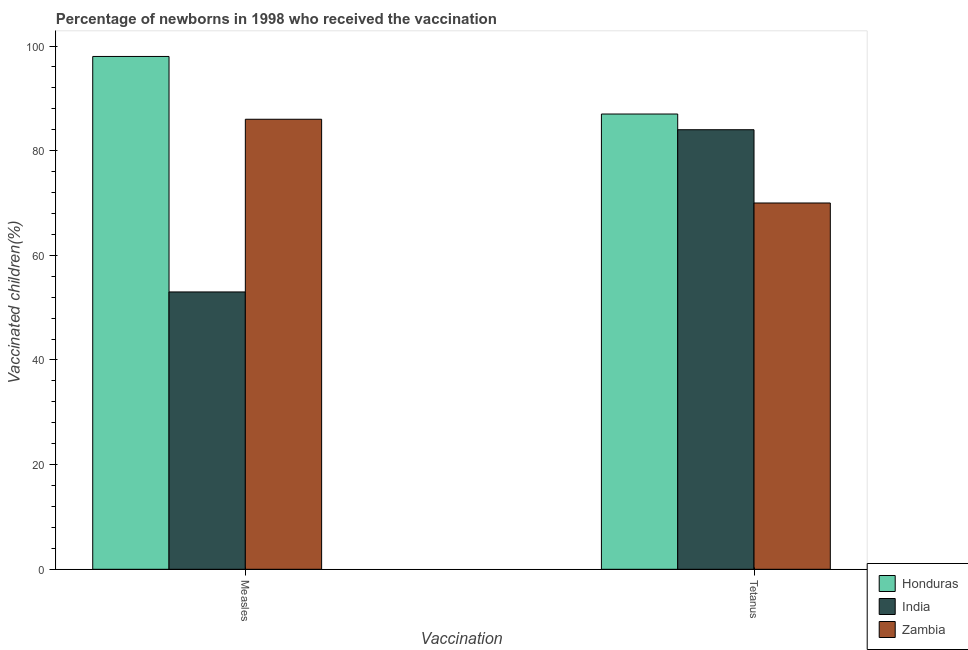How many different coloured bars are there?
Give a very brief answer. 3. Are the number of bars per tick equal to the number of legend labels?
Offer a very short reply. Yes. Are the number of bars on each tick of the X-axis equal?
Provide a succinct answer. Yes. How many bars are there on the 1st tick from the left?
Keep it short and to the point. 3. How many bars are there on the 1st tick from the right?
Your answer should be very brief. 3. What is the label of the 2nd group of bars from the left?
Make the answer very short. Tetanus. What is the percentage of newborns who received vaccination for measles in Honduras?
Provide a succinct answer. 98. Across all countries, what is the maximum percentage of newborns who received vaccination for tetanus?
Offer a very short reply. 87. Across all countries, what is the minimum percentage of newborns who received vaccination for tetanus?
Your response must be concise. 70. In which country was the percentage of newborns who received vaccination for measles maximum?
Ensure brevity in your answer.  Honduras. In which country was the percentage of newborns who received vaccination for measles minimum?
Provide a short and direct response. India. What is the total percentage of newborns who received vaccination for measles in the graph?
Your response must be concise. 237. What is the difference between the percentage of newborns who received vaccination for measles in Honduras and that in India?
Ensure brevity in your answer.  45. What is the difference between the percentage of newborns who received vaccination for measles in Zambia and the percentage of newborns who received vaccination for tetanus in India?
Keep it short and to the point. 2. What is the average percentage of newborns who received vaccination for tetanus per country?
Provide a succinct answer. 80.33. What is the difference between the percentage of newborns who received vaccination for measles and percentage of newborns who received vaccination for tetanus in Honduras?
Provide a short and direct response. 11. What does the 3rd bar from the left in Tetanus represents?
Make the answer very short. Zambia. What does the 3rd bar from the right in Tetanus represents?
Your response must be concise. Honduras. How many bars are there?
Provide a succinct answer. 6. Are all the bars in the graph horizontal?
Provide a succinct answer. No. What is the difference between two consecutive major ticks on the Y-axis?
Your answer should be compact. 20. Are the values on the major ticks of Y-axis written in scientific E-notation?
Provide a short and direct response. No. What is the title of the graph?
Your answer should be very brief. Percentage of newborns in 1998 who received the vaccination. What is the label or title of the X-axis?
Your answer should be very brief. Vaccination. What is the label or title of the Y-axis?
Make the answer very short. Vaccinated children(%)
. What is the Vaccinated children(%)
 of Honduras in Tetanus?
Give a very brief answer. 87. What is the Vaccinated children(%)
 in India in Tetanus?
Ensure brevity in your answer.  84. What is the Vaccinated children(%)
 in Zambia in Tetanus?
Give a very brief answer. 70. Across all Vaccination, what is the maximum Vaccinated children(%)
 in India?
Provide a succinct answer. 84. Across all Vaccination, what is the maximum Vaccinated children(%)
 in Zambia?
Offer a terse response. 86. Across all Vaccination, what is the minimum Vaccinated children(%)
 in Honduras?
Keep it short and to the point. 87. Across all Vaccination, what is the minimum Vaccinated children(%)
 in Zambia?
Ensure brevity in your answer.  70. What is the total Vaccinated children(%)
 in Honduras in the graph?
Offer a terse response. 185. What is the total Vaccinated children(%)
 in India in the graph?
Provide a short and direct response. 137. What is the total Vaccinated children(%)
 in Zambia in the graph?
Provide a succinct answer. 156. What is the difference between the Vaccinated children(%)
 in Honduras in Measles and that in Tetanus?
Offer a very short reply. 11. What is the difference between the Vaccinated children(%)
 of India in Measles and that in Tetanus?
Provide a short and direct response. -31. What is the difference between the Vaccinated children(%)
 in Zambia in Measles and that in Tetanus?
Provide a succinct answer. 16. What is the difference between the Vaccinated children(%)
 in Honduras in Measles and the Vaccinated children(%)
 in India in Tetanus?
Give a very brief answer. 14. What is the difference between the Vaccinated children(%)
 of Honduras in Measles and the Vaccinated children(%)
 of Zambia in Tetanus?
Provide a succinct answer. 28. What is the difference between the Vaccinated children(%)
 in India in Measles and the Vaccinated children(%)
 in Zambia in Tetanus?
Provide a short and direct response. -17. What is the average Vaccinated children(%)
 of Honduras per Vaccination?
Give a very brief answer. 92.5. What is the average Vaccinated children(%)
 of India per Vaccination?
Provide a short and direct response. 68.5. What is the difference between the Vaccinated children(%)
 of Honduras and Vaccinated children(%)
 of India in Measles?
Make the answer very short. 45. What is the difference between the Vaccinated children(%)
 of India and Vaccinated children(%)
 of Zambia in Measles?
Offer a terse response. -33. What is the difference between the Vaccinated children(%)
 in India and Vaccinated children(%)
 in Zambia in Tetanus?
Give a very brief answer. 14. What is the ratio of the Vaccinated children(%)
 in Honduras in Measles to that in Tetanus?
Offer a terse response. 1.13. What is the ratio of the Vaccinated children(%)
 in India in Measles to that in Tetanus?
Provide a succinct answer. 0.63. What is the ratio of the Vaccinated children(%)
 of Zambia in Measles to that in Tetanus?
Keep it short and to the point. 1.23. What is the difference between the highest and the second highest Vaccinated children(%)
 in Honduras?
Offer a terse response. 11. What is the difference between the highest and the second highest Vaccinated children(%)
 in India?
Give a very brief answer. 31. What is the difference between the highest and the second highest Vaccinated children(%)
 in Zambia?
Provide a succinct answer. 16. What is the difference between the highest and the lowest Vaccinated children(%)
 of Zambia?
Make the answer very short. 16. 